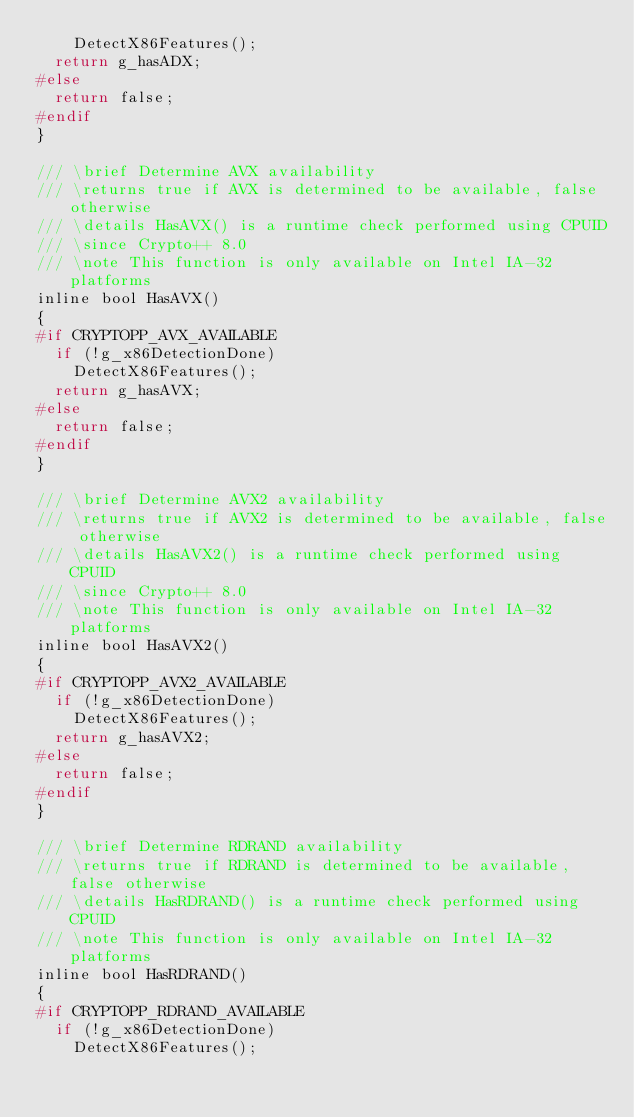<code> <loc_0><loc_0><loc_500><loc_500><_C_>		DetectX86Features();
	return g_hasADX;
#else
	return false;
#endif
}

/// \brief Determine AVX availability
/// \returns true if AVX is determined to be available, false otherwise
/// \details HasAVX() is a runtime check performed using CPUID
/// \since Crypto++ 8.0
/// \note This function is only available on Intel IA-32 platforms
inline bool HasAVX()
{
#if CRYPTOPP_AVX_AVAILABLE
	if (!g_x86DetectionDone)
		DetectX86Features();
	return g_hasAVX;
#else
	return false;
#endif
}

/// \brief Determine AVX2 availability
/// \returns true if AVX2 is determined to be available, false otherwise
/// \details HasAVX2() is a runtime check performed using CPUID
/// \since Crypto++ 8.0
/// \note This function is only available on Intel IA-32 platforms
inline bool HasAVX2()
{
#if CRYPTOPP_AVX2_AVAILABLE
	if (!g_x86DetectionDone)
		DetectX86Features();
	return g_hasAVX2;
#else
	return false;
#endif
}

/// \brief Determine RDRAND availability
/// \returns true if RDRAND is determined to be available, false otherwise
/// \details HasRDRAND() is a runtime check performed using CPUID
/// \note This function is only available on Intel IA-32 platforms
inline bool HasRDRAND()
{
#if CRYPTOPP_RDRAND_AVAILABLE
	if (!g_x86DetectionDone)
		DetectX86Features();</code> 